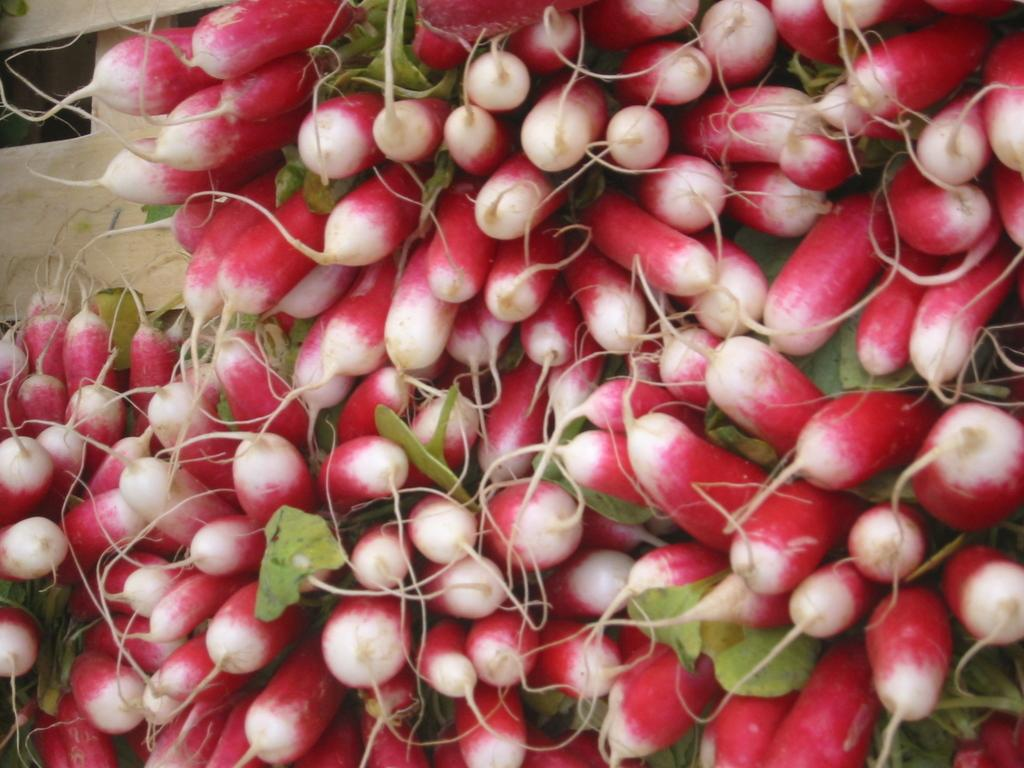What type of food items are present in the image? There are vegetables in the image. What else can be seen in the image besides the vegetables? There are leaves in the image. Can you describe the wooden object in the background of the image? Unfortunately, the facts provided do not give enough information about the wooden object to describe it. What type of lock is used to secure the trousers in the image? There are no trousers or locks present in the image; it only features vegetables and leaves. Can you describe the insect that is crawling on the vegetables in the image? There is no insect present in the image; it only features vegetables and leaves. 